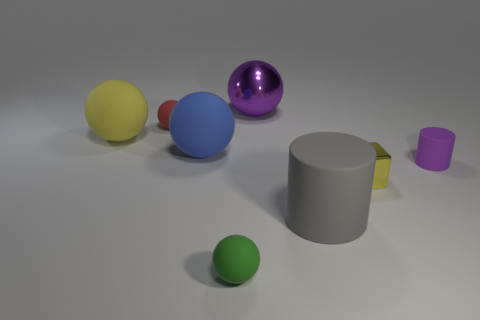Add 1 green matte things. How many objects exist? 9 Subtract all purple balls. How many balls are left? 4 Subtract all metal balls. How many balls are left? 4 Subtract 2 balls. How many balls are left? 3 Subtract all cubes. How many objects are left? 7 Subtract all gray spheres. Subtract all green cubes. How many spheres are left? 5 Subtract 1 yellow cubes. How many objects are left? 7 Subtract all matte spheres. Subtract all big metallic objects. How many objects are left? 3 Add 1 yellow objects. How many yellow objects are left? 3 Add 5 small red rubber things. How many small red rubber things exist? 6 